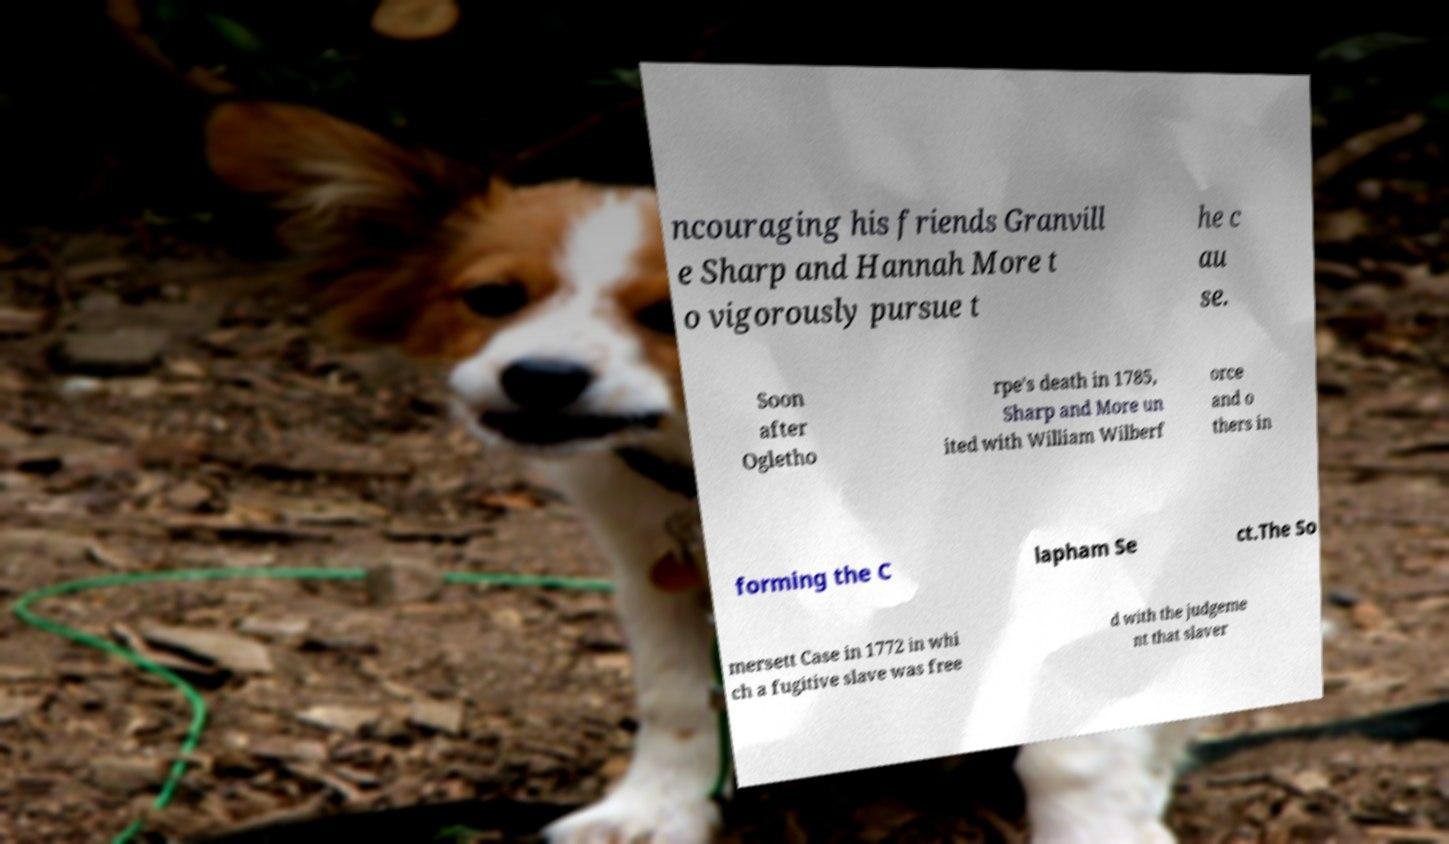Could you extract and type out the text from this image? ncouraging his friends Granvill e Sharp and Hannah More t o vigorously pursue t he c au se. Soon after Ogletho rpe's death in 1785, Sharp and More un ited with William Wilberf orce and o thers in forming the C lapham Se ct.The So mersett Case in 1772 in whi ch a fugitive slave was free d with the judgeme nt that slaver 